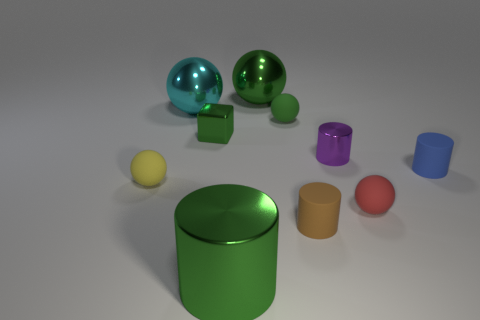Are there any metallic objects that are in front of the tiny ball behind the cube?
Keep it short and to the point. Yes. How many big cyan metal objects are in front of the tiny green block?
Ensure brevity in your answer.  0. There is a small metal thing that is the same shape as the small blue rubber object; what color is it?
Offer a very short reply. Purple. Is the material of the small cylinder in front of the red matte thing the same as the tiny sphere that is behind the blue matte object?
Keep it short and to the point. Yes. Does the big metal cylinder have the same color as the big metallic ball that is to the right of the small green metal cube?
Provide a succinct answer. Yes. What is the shape of the thing that is on the left side of the small purple cylinder and to the right of the small green ball?
Ensure brevity in your answer.  Cylinder. How many blue rubber objects are there?
Make the answer very short. 1. What is the shape of the small object that is the same color as the small block?
Give a very brief answer. Sphere. There is a green matte thing that is the same shape as the red rubber thing; what is its size?
Give a very brief answer. Small. Does the green metallic thing in front of the blue matte thing have the same shape as the tiny purple metal thing?
Make the answer very short. Yes. 